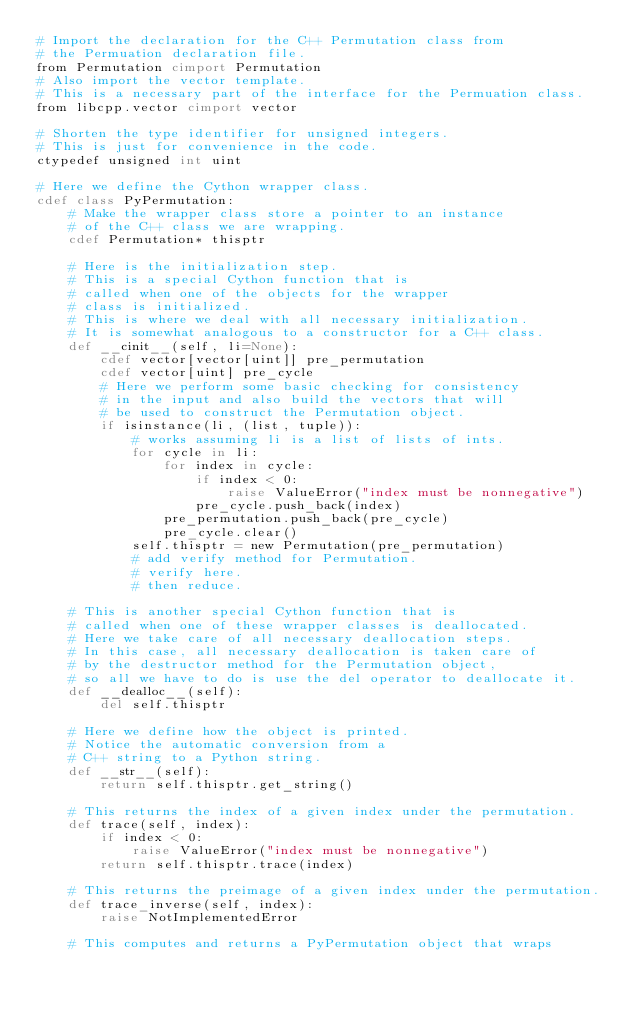<code> <loc_0><loc_0><loc_500><loc_500><_Cython_># Import the declaration for the C++ Permutation class from
# the Permuation declaration file.
from Permutation cimport Permutation
# Also import the vector template.
# This is a necessary part of the interface for the Permuation class.
from libcpp.vector cimport vector

# Shorten the type identifier for unsigned integers.
# This is just for convenience in the code.
ctypedef unsigned int uint

# Here we define the Cython wrapper class.
cdef class PyPermutation:
    # Make the wrapper class store a pointer to an instance
    # of the C++ class we are wrapping.
    cdef Permutation* thisptr
    
    # Here is the initialization step.
    # This is a special Cython function that is
    # called when one of the objects for the wrapper
    # class is initialized.
    # This is where we deal with all necessary initialization.
    # It is somewhat analogous to a constructor for a C++ class.
    def __cinit__(self, li=None):
        cdef vector[vector[uint]] pre_permutation
        cdef vector[uint] pre_cycle
        # Here we perform some basic checking for consistency
        # in the input and also build the vectors that will
        # be used to construct the Permutation object.
        if isinstance(li, (list, tuple)):
            # works assuming li is a list of lists of ints.
            for cycle in li:
                for index in cycle:
                    if index < 0:
                        raise ValueError("index must be nonnegative")
                    pre_cycle.push_back(index)
                pre_permutation.push_back(pre_cycle)
                pre_cycle.clear()
            self.thisptr = new Permutation(pre_permutation)
            # add verify method for Permutation.
            # verify here.
            # then reduce.
    
    # This is another special Cython function that is
    # called when one of these wrapper classes is deallocated.
    # Here we take care of all necessary deallocation steps.
    # In this case, all necessary deallocation is taken care of
    # by the destructor method for the Permutation object,
    # so all we have to do is use the del operator to deallocate it.
    def __dealloc__(self):
        del self.thisptr
    
    # Here we define how the object is printed.
    # Notice the automatic conversion from a
    # C++ string to a Python string.
    def __str__(self):
        return self.thisptr.get_string()
    
    # This returns the index of a given index under the permutation.
    def trace(self, index):
        if index < 0:
            raise ValueError("index must be nonnegative")
        return self.thisptr.trace(index)
    
    # This returns the preimage of a given index under the permutation.
    def trace_inverse(self, index):
        raise NotImplementedError
    
    # This computes and returns a PyPermutation object that wraps</code> 